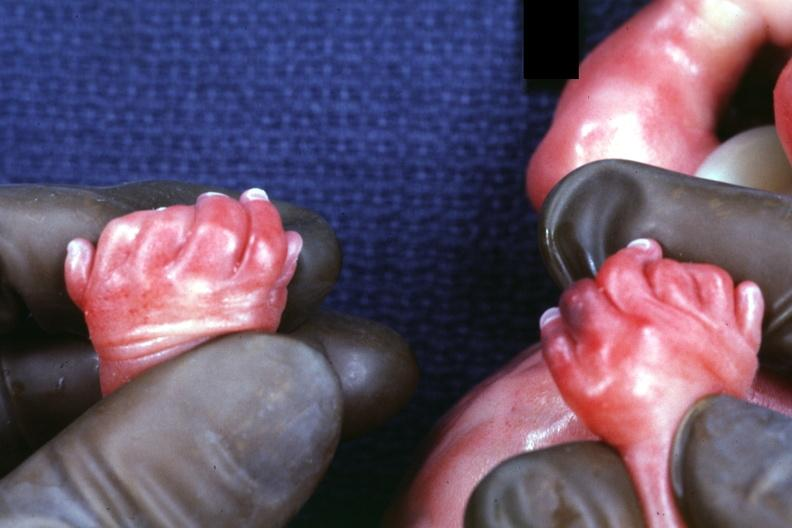how does child have disease?
Answer the question using a single word or phrase. Polycystic 